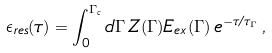<formula> <loc_0><loc_0><loc_500><loc_500>\epsilon _ { r e s } ( \tau ) = \int _ { 0 } ^ { \Gamma _ { c } } d \Gamma \, Z ( \Gamma ) E _ { e x } ( \Gamma ) \, e ^ { - \tau / \tau _ { \Gamma } } \, ,</formula> 